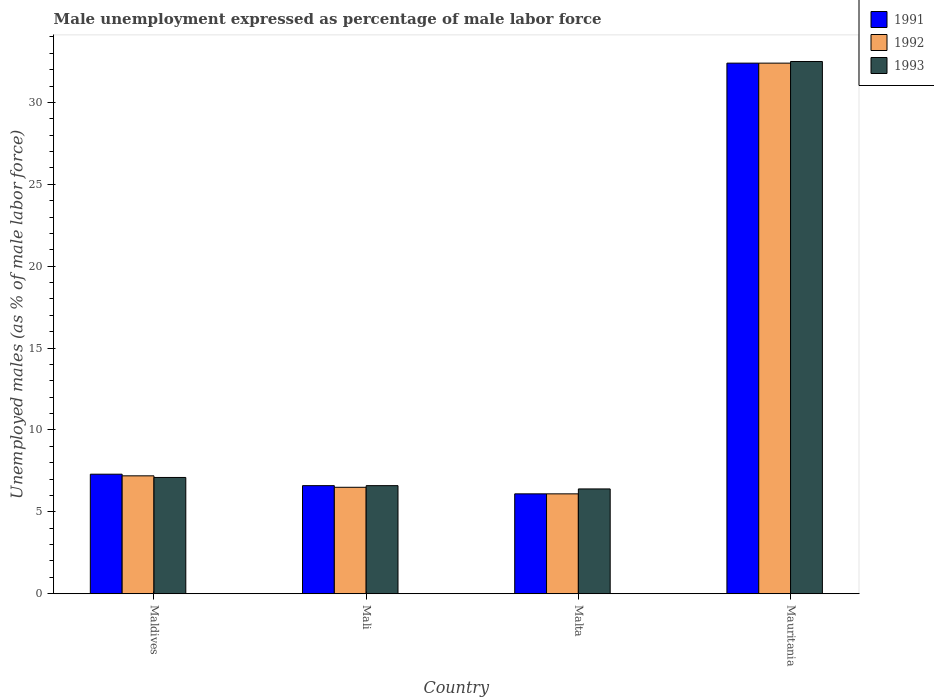Are the number of bars per tick equal to the number of legend labels?
Provide a short and direct response. Yes. How many bars are there on the 2nd tick from the left?
Make the answer very short. 3. How many bars are there on the 1st tick from the right?
Your response must be concise. 3. What is the label of the 1st group of bars from the left?
Your response must be concise. Maldives. In how many cases, is the number of bars for a given country not equal to the number of legend labels?
Offer a terse response. 0. What is the unemployment in males in in 1992 in Malta?
Your response must be concise. 6.1. Across all countries, what is the maximum unemployment in males in in 1993?
Provide a short and direct response. 32.5. Across all countries, what is the minimum unemployment in males in in 1993?
Provide a short and direct response. 6.4. In which country was the unemployment in males in in 1991 maximum?
Ensure brevity in your answer.  Mauritania. In which country was the unemployment in males in in 1993 minimum?
Your response must be concise. Malta. What is the total unemployment in males in in 1993 in the graph?
Keep it short and to the point. 52.6. What is the difference between the unemployment in males in in 1993 in Mali and that in Malta?
Offer a very short reply. 0.2. What is the difference between the unemployment in males in in 1991 in Mauritania and the unemployment in males in in 1993 in Mali?
Give a very brief answer. 25.8. What is the average unemployment in males in in 1992 per country?
Offer a very short reply. 13.05. What is the difference between the unemployment in males in of/in 1993 and unemployment in males in of/in 1992 in Malta?
Keep it short and to the point. 0.3. In how many countries, is the unemployment in males in in 1991 greater than 8 %?
Your response must be concise. 1. What is the ratio of the unemployment in males in in 1993 in Mali to that in Malta?
Your answer should be very brief. 1.03. What is the difference between the highest and the second highest unemployment in males in in 1992?
Provide a succinct answer. 25.9. What is the difference between the highest and the lowest unemployment in males in in 1993?
Give a very brief answer. 26.1. In how many countries, is the unemployment in males in in 1993 greater than the average unemployment in males in in 1993 taken over all countries?
Provide a succinct answer. 1. What does the 2nd bar from the left in Mauritania represents?
Give a very brief answer. 1992. What does the 2nd bar from the right in Maldives represents?
Ensure brevity in your answer.  1992. Is it the case that in every country, the sum of the unemployment in males in in 1993 and unemployment in males in in 1991 is greater than the unemployment in males in in 1992?
Give a very brief answer. Yes. Are all the bars in the graph horizontal?
Make the answer very short. No. How many countries are there in the graph?
Keep it short and to the point. 4. What is the difference between two consecutive major ticks on the Y-axis?
Ensure brevity in your answer.  5. Are the values on the major ticks of Y-axis written in scientific E-notation?
Ensure brevity in your answer.  No. Does the graph contain any zero values?
Provide a succinct answer. No. How many legend labels are there?
Make the answer very short. 3. How are the legend labels stacked?
Give a very brief answer. Vertical. What is the title of the graph?
Give a very brief answer. Male unemployment expressed as percentage of male labor force. What is the label or title of the Y-axis?
Your response must be concise. Unemployed males (as % of male labor force). What is the Unemployed males (as % of male labor force) in 1991 in Maldives?
Your response must be concise. 7.3. What is the Unemployed males (as % of male labor force) of 1992 in Maldives?
Make the answer very short. 7.2. What is the Unemployed males (as % of male labor force) in 1993 in Maldives?
Offer a terse response. 7.1. What is the Unemployed males (as % of male labor force) in 1991 in Mali?
Offer a terse response. 6.6. What is the Unemployed males (as % of male labor force) in 1993 in Mali?
Ensure brevity in your answer.  6.6. What is the Unemployed males (as % of male labor force) of 1991 in Malta?
Your answer should be very brief. 6.1. What is the Unemployed males (as % of male labor force) in 1992 in Malta?
Your response must be concise. 6.1. What is the Unemployed males (as % of male labor force) in 1993 in Malta?
Offer a terse response. 6.4. What is the Unemployed males (as % of male labor force) in 1991 in Mauritania?
Ensure brevity in your answer.  32.4. What is the Unemployed males (as % of male labor force) of 1992 in Mauritania?
Make the answer very short. 32.4. What is the Unemployed males (as % of male labor force) of 1993 in Mauritania?
Give a very brief answer. 32.5. Across all countries, what is the maximum Unemployed males (as % of male labor force) in 1991?
Offer a terse response. 32.4. Across all countries, what is the maximum Unemployed males (as % of male labor force) of 1992?
Your answer should be compact. 32.4. Across all countries, what is the maximum Unemployed males (as % of male labor force) of 1993?
Your response must be concise. 32.5. Across all countries, what is the minimum Unemployed males (as % of male labor force) of 1991?
Provide a succinct answer. 6.1. Across all countries, what is the minimum Unemployed males (as % of male labor force) in 1992?
Keep it short and to the point. 6.1. Across all countries, what is the minimum Unemployed males (as % of male labor force) in 1993?
Make the answer very short. 6.4. What is the total Unemployed males (as % of male labor force) in 1991 in the graph?
Ensure brevity in your answer.  52.4. What is the total Unemployed males (as % of male labor force) in 1992 in the graph?
Keep it short and to the point. 52.2. What is the total Unemployed males (as % of male labor force) in 1993 in the graph?
Provide a short and direct response. 52.6. What is the difference between the Unemployed males (as % of male labor force) of 1991 in Maldives and that in Mali?
Provide a succinct answer. 0.7. What is the difference between the Unemployed males (as % of male labor force) in 1993 in Maldives and that in Mali?
Offer a very short reply. 0.5. What is the difference between the Unemployed males (as % of male labor force) in 1992 in Maldives and that in Malta?
Offer a terse response. 1.1. What is the difference between the Unemployed males (as % of male labor force) in 1991 in Maldives and that in Mauritania?
Provide a short and direct response. -25.1. What is the difference between the Unemployed males (as % of male labor force) in 1992 in Maldives and that in Mauritania?
Ensure brevity in your answer.  -25.2. What is the difference between the Unemployed males (as % of male labor force) in 1993 in Maldives and that in Mauritania?
Keep it short and to the point. -25.4. What is the difference between the Unemployed males (as % of male labor force) in 1991 in Mali and that in Malta?
Make the answer very short. 0.5. What is the difference between the Unemployed males (as % of male labor force) of 1991 in Mali and that in Mauritania?
Your response must be concise. -25.8. What is the difference between the Unemployed males (as % of male labor force) in 1992 in Mali and that in Mauritania?
Give a very brief answer. -25.9. What is the difference between the Unemployed males (as % of male labor force) of 1993 in Mali and that in Mauritania?
Ensure brevity in your answer.  -25.9. What is the difference between the Unemployed males (as % of male labor force) in 1991 in Malta and that in Mauritania?
Make the answer very short. -26.3. What is the difference between the Unemployed males (as % of male labor force) in 1992 in Malta and that in Mauritania?
Provide a succinct answer. -26.3. What is the difference between the Unemployed males (as % of male labor force) in 1993 in Malta and that in Mauritania?
Your response must be concise. -26.1. What is the difference between the Unemployed males (as % of male labor force) in 1991 in Maldives and the Unemployed males (as % of male labor force) in 1992 in Mali?
Provide a short and direct response. 0.8. What is the difference between the Unemployed males (as % of male labor force) of 1992 in Maldives and the Unemployed males (as % of male labor force) of 1993 in Mali?
Give a very brief answer. 0.6. What is the difference between the Unemployed males (as % of male labor force) of 1991 in Maldives and the Unemployed males (as % of male labor force) of 1993 in Malta?
Your response must be concise. 0.9. What is the difference between the Unemployed males (as % of male labor force) of 1992 in Maldives and the Unemployed males (as % of male labor force) of 1993 in Malta?
Your response must be concise. 0.8. What is the difference between the Unemployed males (as % of male labor force) of 1991 in Maldives and the Unemployed males (as % of male labor force) of 1992 in Mauritania?
Provide a short and direct response. -25.1. What is the difference between the Unemployed males (as % of male labor force) in 1991 in Maldives and the Unemployed males (as % of male labor force) in 1993 in Mauritania?
Your response must be concise. -25.2. What is the difference between the Unemployed males (as % of male labor force) in 1992 in Maldives and the Unemployed males (as % of male labor force) in 1993 in Mauritania?
Provide a short and direct response. -25.3. What is the difference between the Unemployed males (as % of male labor force) in 1991 in Mali and the Unemployed males (as % of male labor force) in 1992 in Malta?
Provide a short and direct response. 0.5. What is the difference between the Unemployed males (as % of male labor force) in 1991 in Mali and the Unemployed males (as % of male labor force) in 1992 in Mauritania?
Your answer should be very brief. -25.8. What is the difference between the Unemployed males (as % of male labor force) of 1991 in Mali and the Unemployed males (as % of male labor force) of 1993 in Mauritania?
Keep it short and to the point. -25.9. What is the difference between the Unemployed males (as % of male labor force) in 1991 in Malta and the Unemployed males (as % of male labor force) in 1992 in Mauritania?
Ensure brevity in your answer.  -26.3. What is the difference between the Unemployed males (as % of male labor force) of 1991 in Malta and the Unemployed males (as % of male labor force) of 1993 in Mauritania?
Provide a succinct answer. -26.4. What is the difference between the Unemployed males (as % of male labor force) of 1992 in Malta and the Unemployed males (as % of male labor force) of 1993 in Mauritania?
Provide a short and direct response. -26.4. What is the average Unemployed males (as % of male labor force) in 1992 per country?
Offer a very short reply. 13.05. What is the average Unemployed males (as % of male labor force) of 1993 per country?
Give a very brief answer. 13.15. What is the difference between the Unemployed males (as % of male labor force) in 1991 and Unemployed males (as % of male labor force) in 1993 in Maldives?
Give a very brief answer. 0.2. What is the difference between the Unemployed males (as % of male labor force) in 1991 and Unemployed males (as % of male labor force) in 1993 in Mali?
Provide a succinct answer. 0. What is the difference between the Unemployed males (as % of male labor force) in 1991 and Unemployed males (as % of male labor force) in 1992 in Malta?
Ensure brevity in your answer.  0. What is the difference between the Unemployed males (as % of male labor force) of 1992 and Unemployed males (as % of male labor force) of 1993 in Malta?
Ensure brevity in your answer.  -0.3. What is the difference between the Unemployed males (as % of male labor force) of 1992 and Unemployed males (as % of male labor force) of 1993 in Mauritania?
Your answer should be compact. -0.1. What is the ratio of the Unemployed males (as % of male labor force) in 1991 in Maldives to that in Mali?
Your answer should be very brief. 1.11. What is the ratio of the Unemployed males (as % of male labor force) of 1992 in Maldives to that in Mali?
Give a very brief answer. 1.11. What is the ratio of the Unemployed males (as % of male labor force) in 1993 in Maldives to that in Mali?
Provide a succinct answer. 1.08. What is the ratio of the Unemployed males (as % of male labor force) of 1991 in Maldives to that in Malta?
Your answer should be very brief. 1.2. What is the ratio of the Unemployed males (as % of male labor force) of 1992 in Maldives to that in Malta?
Keep it short and to the point. 1.18. What is the ratio of the Unemployed males (as % of male labor force) of 1993 in Maldives to that in Malta?
Keep it short and to the point. 1.11. What is the ratio of the Unemployed males (as % of male labor force) in 1991 in Maldives to that in Mauritania?
Provide a succinct answer. 0.23. What is the ratio of the Unemployed males (as % of male labor force) of 1992 in Maldives to that in Mauritania?
Offer a very short reply. 0.22. What is the ratio of the Unemployed males (as % of male labor force) in 1993 in Maldives to that in Mauritania?
Ensure brevity in your answer.  0.22. What is the ratio of the Unemployed males (as % of male labor force) of 1991 in Mali to that in Malta?
Offer a terse response. 1.08. What is the ratio of the Unemployed males (as % of male labor force) of 1992 in Mali to that in Malta?
Make the answer very short. 1.07. What is the ratio of the Unemployed males (as % of male labor force) of 1993 in Mali to that in Malta?
Offer a terse response. 1.03. What is the ratio of the Unemployed males (as % of male labor force) in 1991 in Mali to that in Mauritania?
Your response must be concise. 0.2. What is the ratio of the Unemployed males (as % of male labor force) of 1992 in Mali to that in Mauritania?
Your answer should be compact. 0.2. What is the ratio of the Unemployed males (as % of male labor force) of 1993 in Mali to that in Mauritania?
Keep it short and to the point. 0.2. What is the ratio of the Unemployed males (as % of male labor force) in 1991 in Malta to that in Mauritania?
Provide a succinct answer. 0.19. What is the ratio of the Unemployed males (as % of male labor force) in 1992 in Malta to that in Mauritania?
Your answer should be very brief. 0.19. What is the ratio of the Unemployed males (as % of male labor force) of 1993 in Malta to that in Mauritania?
Make the answer very short. 0.2. What is the difference between the highest and the second highest Unemployed males (as % of male labor force) of 1991?
Provide a succinct answer. 25.1. What is the difference between the highest and the second highest Unemployed males (as % of male labor force) in 1992?
Provide a short and direct response. 25.2. What is the difference between the highest and the second highest Unemployed males (as % of male labor force) of 1993?
Give a very brief answer. 25.4. What is the difference between the highest and the lowest Unemployed males (as % of male labor force) of 1991?
Your answer should be compact. 26.3. What is the difference between the highest and the lowest Unemployed males (as % of male labor force) of 1992?
Provide a succinct answer. 26.3. What is the difference between the highest and the lowest Unemployed males (as % of male labor force) in 1993?
Offer a terse response. 26.1. 